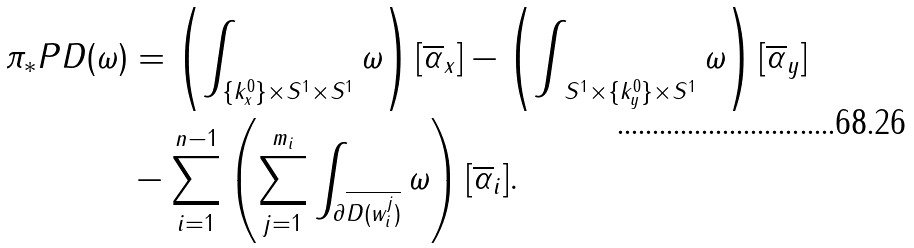Convert formula to latex. <formula><loc_0><loc_0><loc_500><loc_500>\pi _ { * } P D ( \omega ) & = \left ( \int _ { \{ k ^ { 0 } _ { x } \} \times S ^ { 1 } \times S ^ { 1 } } \omega \right ) [ \overline { \alpha } _ { x } ] - \left ( \int _ { \ S ^ { 1 } \times \{ k ^ { 0 } _ { y } \} \times S ^ { 1 } } \omega \right ) [ \overline { \alpha } _ { y } ] \\ & - \sum _ { i = 1 } ^ { n - 1 } \left ( \sum _ { j = 1 } ^ { m _ { i } } \int _ { \partial \overline { D ( w _ { i } ^ { j } ) } } \omega \right ) [ \overline { \alpha } _ { i } ] .</formula> 